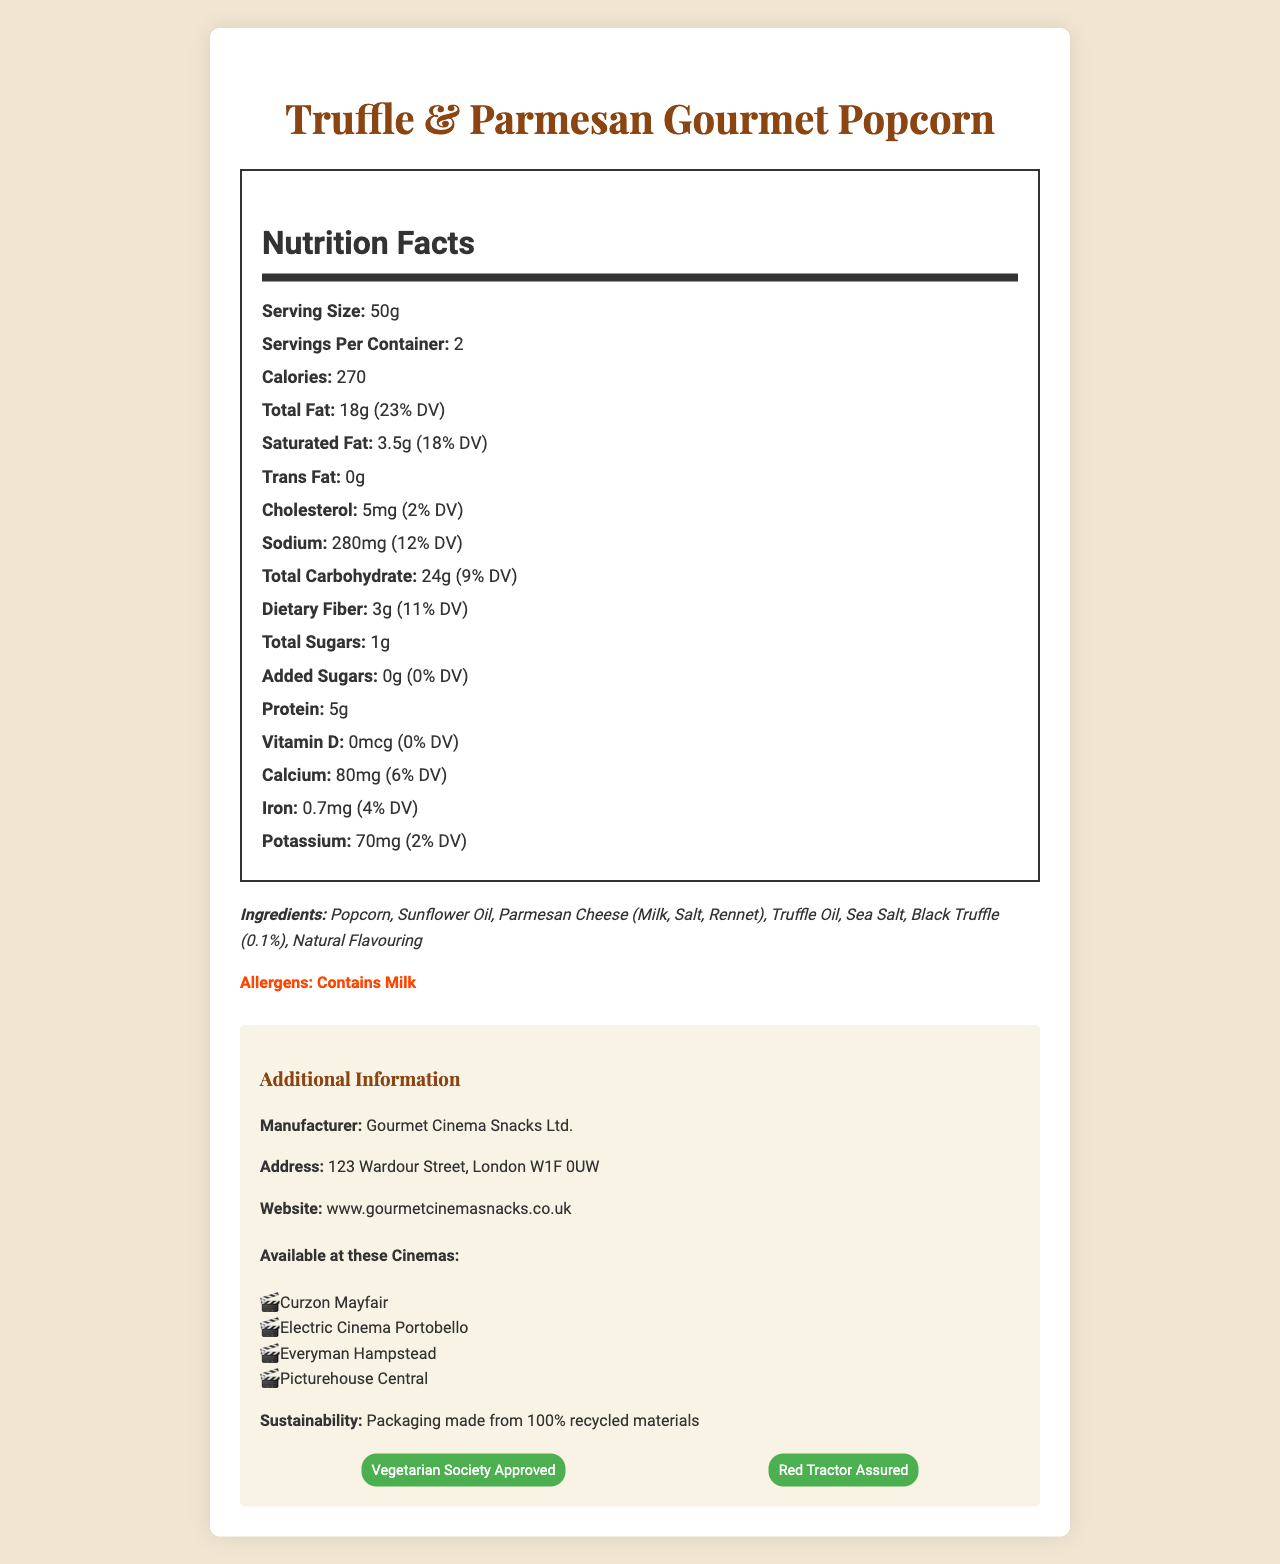what is the serving size for the Truffle & Parmesan Gourmet Popcorn? The serving size is explicitly mentioned in the nutrition label as 50g.
Answer: 50g how many calories are in one serving? The nutrition label specifies that each serving contains 270 calories.
Answer: 270 calories what is the total fat content per serving, including the daily value percentage? The label states that the total fat content per serving is 18g, which is 23% of the daily value.
Answer: 18g (23% DV) how much dietary fiber is in each serving? The document indicates that each serving has 3g of dietary fiber.
Answer: 3g what are the allergens listed on the label? The allergen section clearly states that the product contains milk.
Answer: Contains Milk which additional certifications does this popcorn have? A. Fairtrade B. Vegetarian Society Approved C. Red Tractor Assured D. Both B and C The certifications listed are "Vegetarian Society Approved" and "Red Tractor Assured."
Answer: D where can this gourmet popcorn be purchased in London? A. Curzon Mayfair B. Electric Cinema Portobello C. Everyman Hampstead D. Picturehouse Central E. All of the Above The document lists Curzon Mayfair, Electric Cinema Portobello, Everyman Hampstead, and Picturehouse Central, making all options correct.
Answer: E does the product contain any trans fat? The label mentions that the trans fat amount is 0g.
Answer: No is the packaging of the popcorn environmentally friendly? The additional information section states that the packaging is made from 100% recycled materials.
Answer: Yes give a brief summary of the document. This summary describes the comprehensive details found in the document, covering all major sections and points.
Answer: The document provides nutrition facts for Truffle & Parmesan Gourmet Popcorn, listing serving size, calorie content, fats, carbohydrates, protein, vitamins, and minerals. It includes the ingredients and allergens, mentions that packaging is eco-friendly, lists the manufacturer's details and where the product can be purchased in London cinemas, and shows its certifications. what type of oil is used in the Truffle & Parmesan Gourmet Popcorn? The ingredients list clearly shows that Sunflower Oil is used.
Answer: Sunflower Oil how much calcium does one serving provide? The nutrition label specifies that one serving includes 80mg of calcium, which is 6% of the daily value.
Answer: 80mg (6% DV) which ingredient is present in the smallest quantity? The label mentions Black Truffle at 0.1%, indicating it is the smallest quantity ingredient.
Answer: Black Truffle (0.1%) what is the street address of Gourmet Cinema Snacks Ltd.? The additional information section lists the manufacturer's address as 123 Wardour Street, London W1F 0UW.
Answer: 123 Wardour Street, London W1F 0UW how much protein is in a full container of the product? With 5g of protein per serving and 2 servings per container, the total protein is 10g.
Answer: 10g how much vitamin D is contained in the product? The nutrition label states that the product contains 0mcg of vitamin D, which is 0% of the daily value.
Answer: 0mcg (0% DV) what is the daily value percentage of potassium in a serving? The daily value percentage for potassium in each serving is listed as 2%.
Answer: 2% how many servings are in one container? The label clearly states there are 2 servings per container.
Answer: 2 what is the URL for the manufacturer's website? Under additional information, the website URL given is www.gourmetcinemasnacks.co.uk.
Answer: www.gourmetcinemasnacks.co.uk how much sugar is added to this product? The nutrition label shows that the product has 0g of added sugars.
Answer: 0g what is the price of the product? The document does not provide any information regarding the price of the product.
Answer: Cannot be determined 